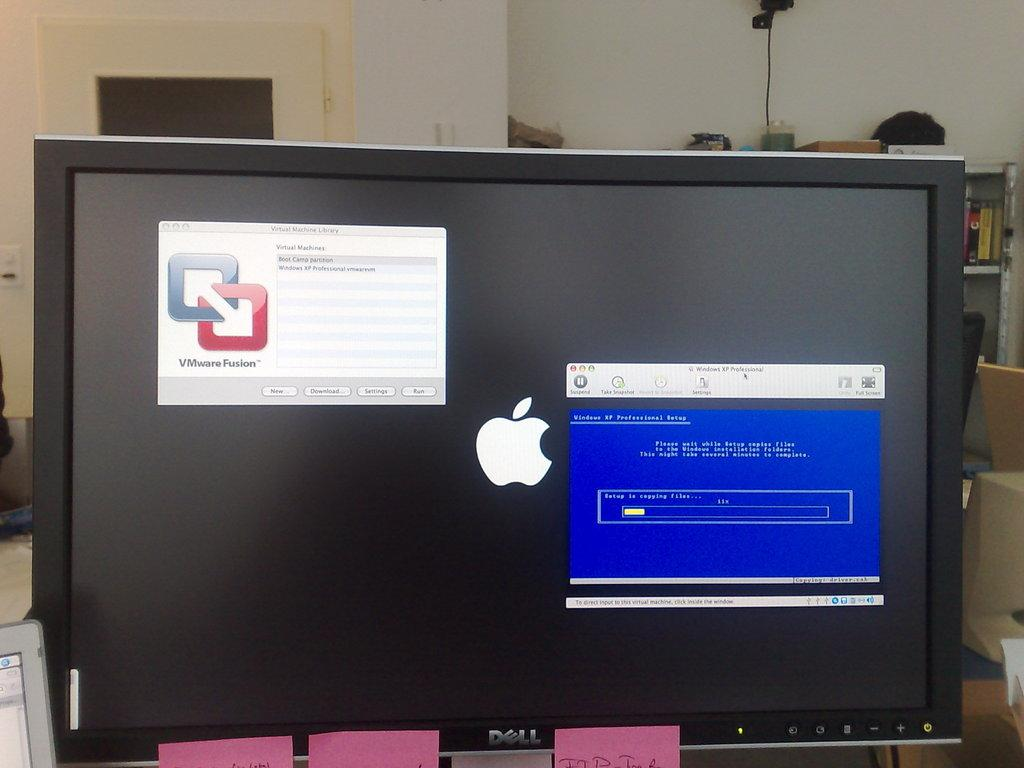<image>
Describe the image concisely. A VMware Fusion window is open on a Dell computer with the MAC logo in the middle. 